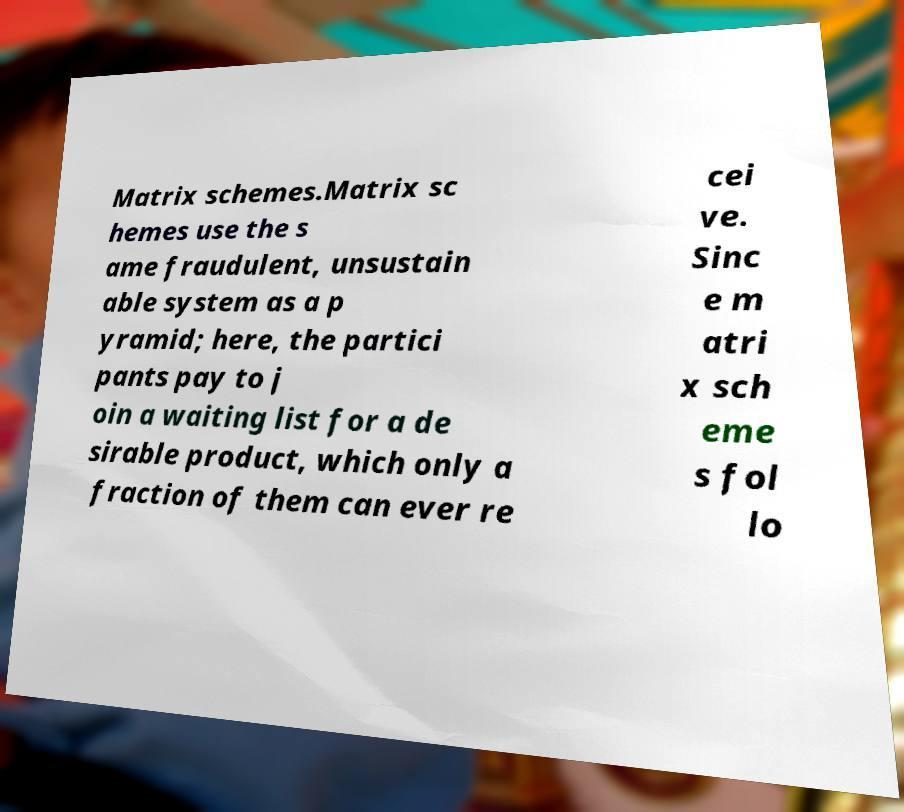For documentation purposes, I need the text within this image transcribed. Could you provide that? Matrix schemes.Matrix sc hemes use the s ame fraudulent, unsustain able system as a p yramid; here, the partici pants pay to j oin a waiting list for a de sirable product, which only a fraction of them can ever re cei ve. Sinc e m atri x sch eme s fol lo 